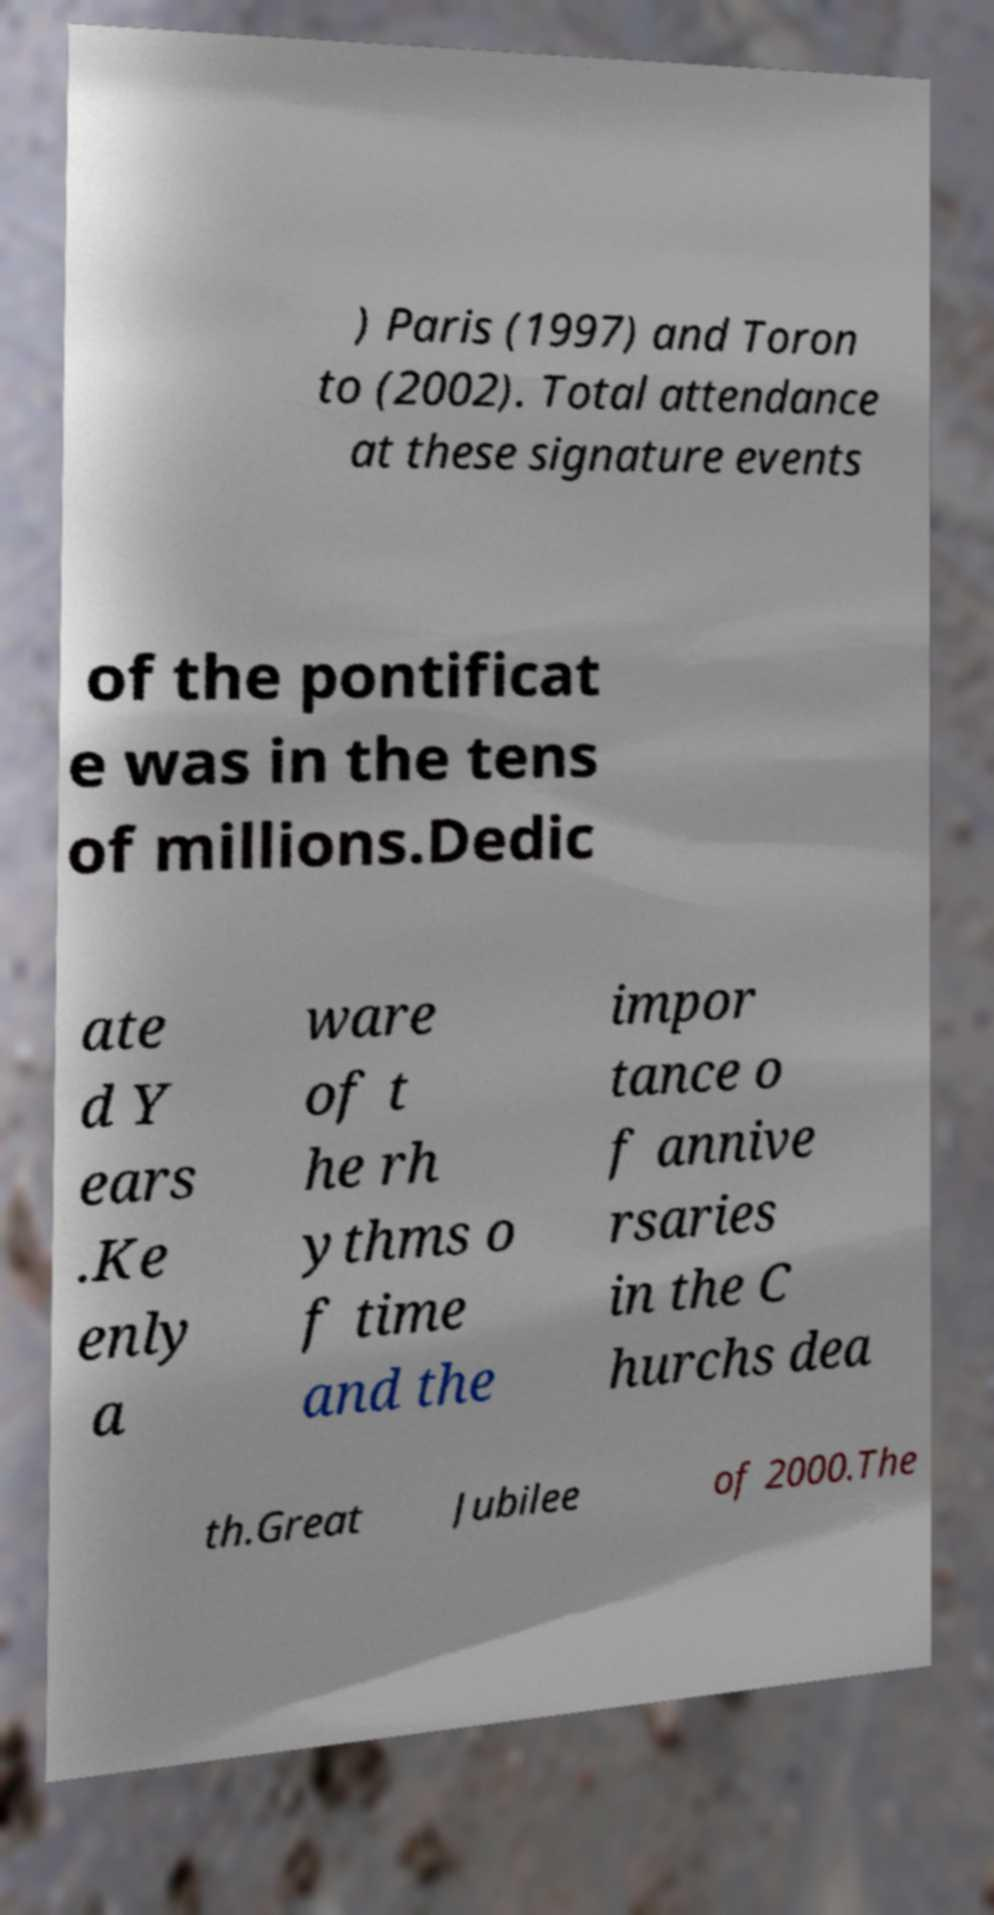For documentation purposes, I need the text within this image transcribed. Could you provide that? ) Paris (1997) and Toron to (2002). Total attendance at these signature events of the pontificat e was in the tens of millions.Dedic ate d Y ears .Ke enly a ware of t he rh ythms o f time and the impor tance o f annive rsaries in the C hurchs dea th.Great Jubilee of 2000.The 